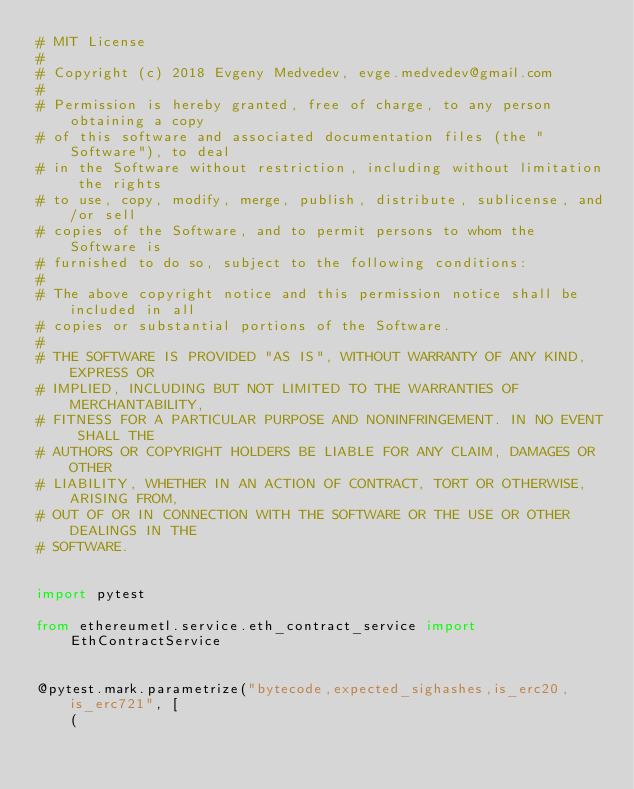Convert code to text. <code><loc_0><loc_0><loc_500><loc_500><_Python_># MIT License
#
# Copyright (c) 2018 Evgeny Medvedev, evge.medvedev@gmail.com
#
# Permission is hereby granted, free of charge, to any person obtaining a copy
# of this software and associated documentation files (the "Software"), to deal
# in the Software without restriction, including without limitation the rights
# to use, copy, modify, merge, publish, distribute, sublicense, and/or sell
# copies of the Software, and to permit persons to whom the Software is
# furnished to do so, subject to the following conditions:
#
# The above copyright notice and this permission notice shall be included in all
# copies or substantial portions of the Software.
#
# THE SOFTWARE IS PROVIDED "AS IS", WITHOUT WARRANTY OF ANY KIND, EXPRESS OR
# IMPLIED, INCLUDING BUT NOT LIMITED TO THE WARRANTIES OF MERCHANTABILITY,
# FITNESS FOR A PARTICULAR PURPOSE AND NONINFRINGEMENT. IN NO EVENT SHALL THE
# AUTHORS OR COPYRIGHT HOLDERS BE LIABLE FOR ANY CLAIM, DAMAGES OR OTHER
# LIABILITY, WHETHER IN AN ACTION OF CONTRACT, TORT OR OTHERWISE, ARISING FROM,
# OUT OF OR IN CONNECTION WITH THE SOFTWARE OR THE USE OR OTHER DEALINGS IN THE
# SOFTWARE.


import pytest

from ethereumetl.service.eth_contract_service import EthContractService


@pytest.mark.parametrize("bytecode,expected_sighashes,is_erc20,is_erc721", [
    (</code> 